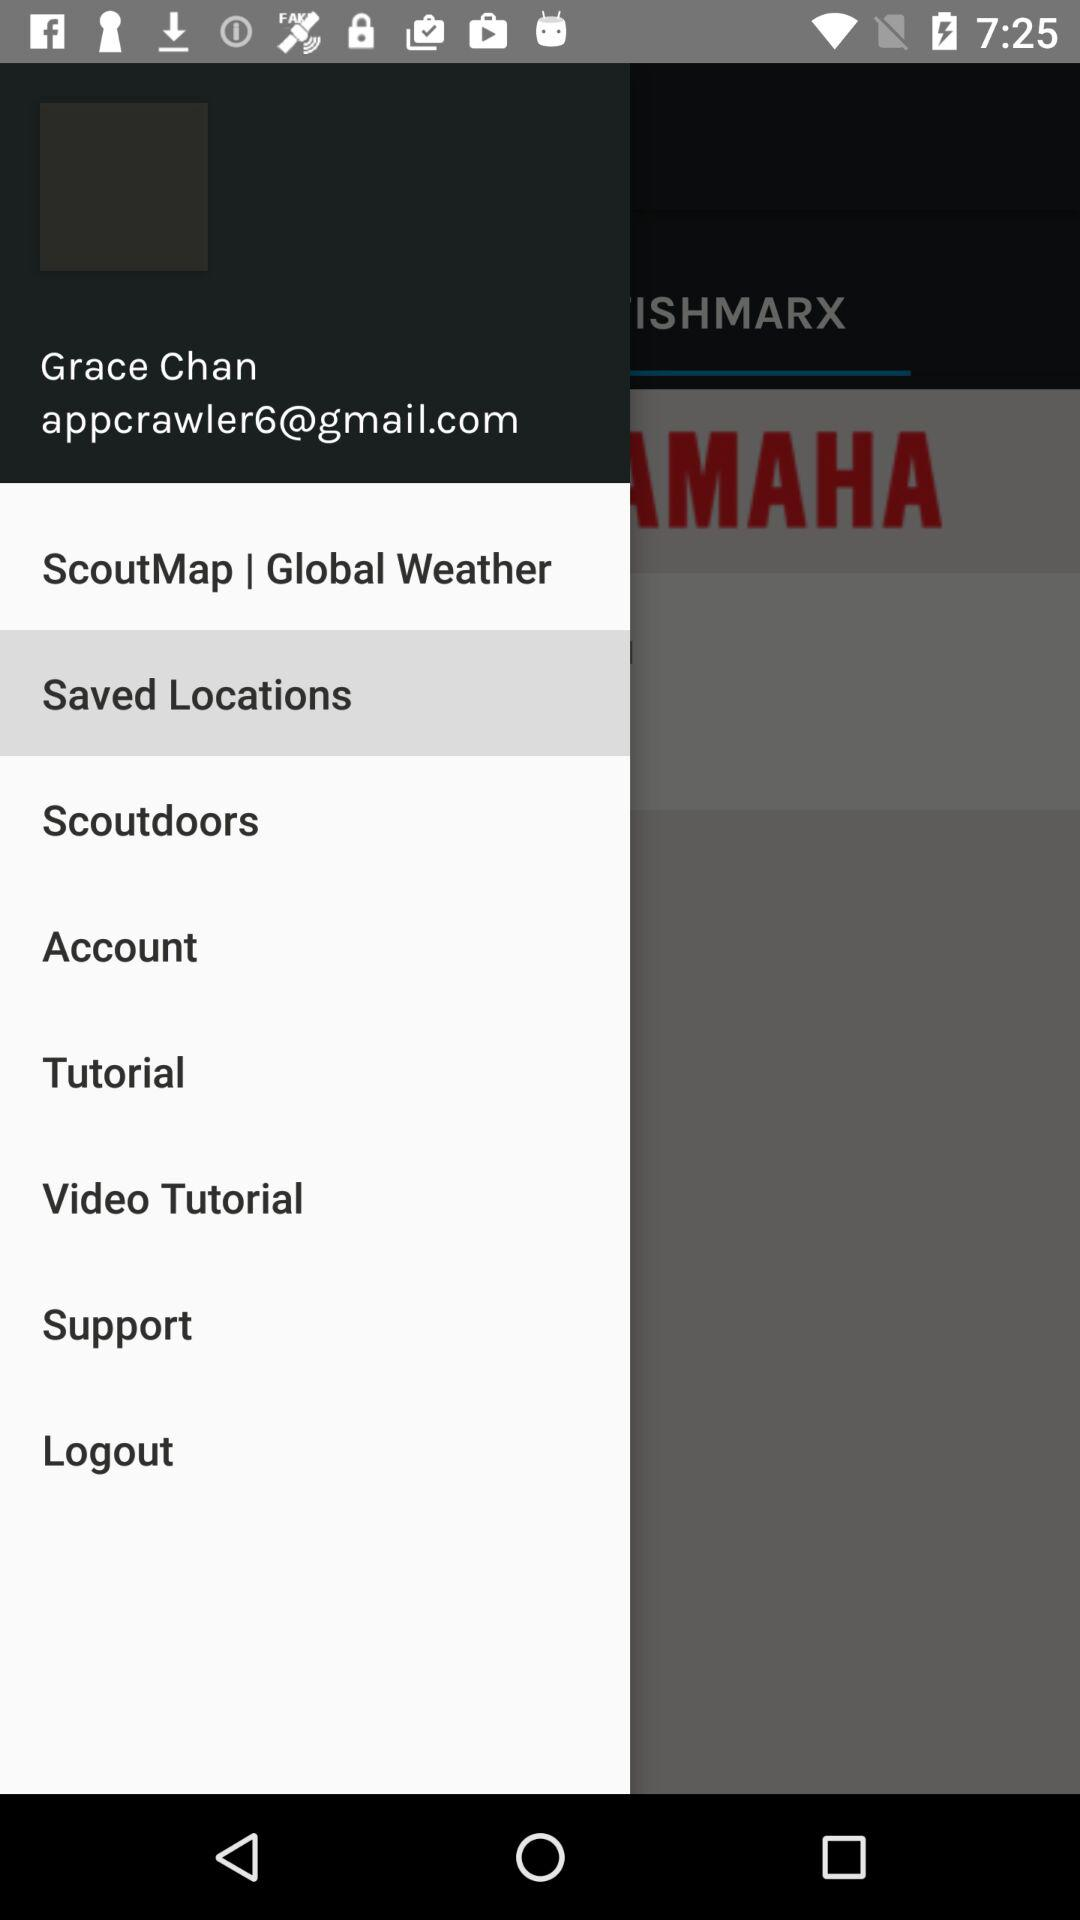What is the name? The name is Grace Chan. 